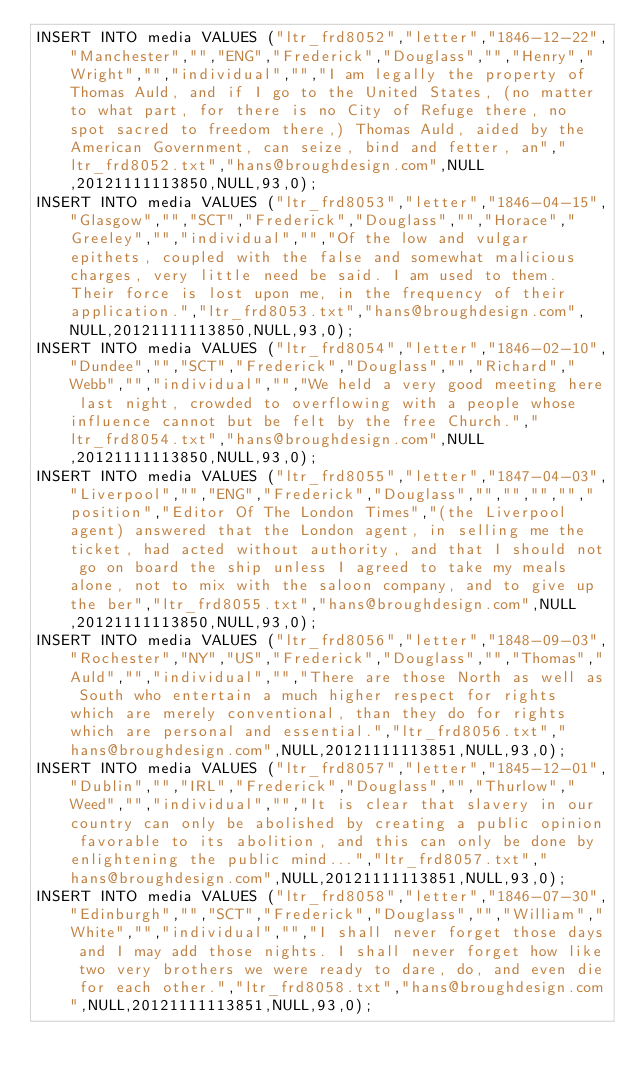<code> <loc_0><loc_0><loc_500><loc_500><_SQL_>INSERT INTO media VALUES ("ltr_frd8052","letter","1846-12-22","Manchester","","ENG","Frederick","Douglass","","Henry","Wright","","individual","","I am legally the property of Thomas Auld, and if I go to the United States, (no matter to what part, for there is no City of Refuge there, no spot sacred to freedom there,) Thomas Auld, aided by the American Government, can seize, bind and fetter, an","ltr_frd8052.txt","hans@broughdesign.com",NULL,20121111113850,NULL,93,0);
INSERT INTO media VALUES ("ltr_frd8053","letter","1846-04-15","Glasgow","","SCT","Frederick","Douglass","","Horace","Greeley","","individual","","Of the low and vulgar epithets, coupled with the false and somewhat malicious charges, very little need be said. I am used to them. Their force is lost upon me, in the frequency of their application.","ltr_frd8053.txt","hans@broughdesign.com",NULL,20121111113850,NULL,93,0);
INSERT INTO media VALUES ("ltr_frd8054","letter","1846-02-10","Dundee","","SCT","Frederick","Douglass","","Richard","Webb","","individual","","We held a very good meeting here last night, crowded to overflowing with a people whose influence cannot but be felt by the free Church.","ltr_frd8054.txt","hans@broughdesign.com",NULL,20121111113850,NULL,93,0);
INSERT INTO media VALUES ("ltr_frd8055","letter","1847-04-03","Liverpool","","ENG","Frederick","Douglass","","","","","position","Editor Of The London Times","(the Liverpool agent) answered that the London agent, in selling me the ticket, had acted without authority, and that I should not go on board the ship unless I agreed to take my meals alone, not to mix with the saloon company, and to give up the ber","ltr_frd8055.txt","hans@broughdesign.com",NULL,20121111113850,NULL,93,0);
INSERT INTO media VALUES ("ltr_frd8056","letter","1848-09-03","Rochester","NY","US","Frederick","Douglass","","Thomas","Auld","","individual","","There are those North as well as South who entertain a much higher respect for rights which are merely conventional, than they do for rights which are personal and essential.","ltr_frd8056.txt","hans@broughdesign.com",NULL,20121111113851,NULL,93,0);
INSERT INTO media VALUES ("ltr_frd8057","letter","1845-12-01","Dublin","","IRL","Frederick","Douglass","","Thurlow","Weed","","individual","","It is clear that slavery in our country can only be abolished by creating a public opinion favorable to its abolition, and this can only be done by enlightening the public mind...","ltr_frd8057.txt","hans@broughdesign.com",NULL,20121111113851,NULL,93,0);
INSERT INTO media VALUES ("ltr_frd8058","letter","1846-07-30","Edinburgh","","SCT","Frederick","Douglass","","William","White","","individual","","I shall never forget those days and I may add those nights. I shall never forget how like two very brothers we were ready to dare, do, and even die for each other.","ltr_frd8058.txt","hans@broughdesign.com",NULL,20121111113851,NULL,93,0);</code> 